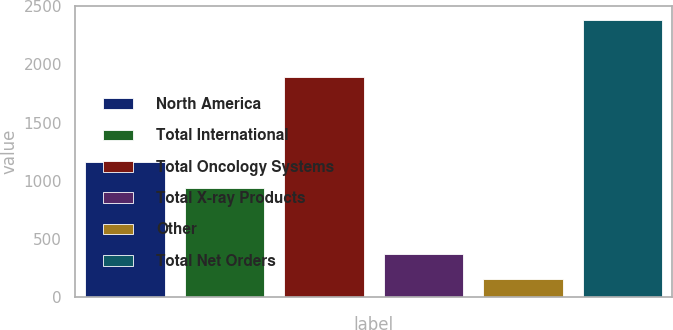Convert chart. <chart><loc_0><loc_0><loc_500><loc_500><bar_chart><fcel>North America<fcel>Total International<fcel>Total Oncology Systems<fcel>Total X-ray Products<fcel>Other<fcel>Total Net Orders<nl><fcel>1165<fcel>942<fcel>1891<fcel>374<fcel>151<fcel>2381<nl></chart> 